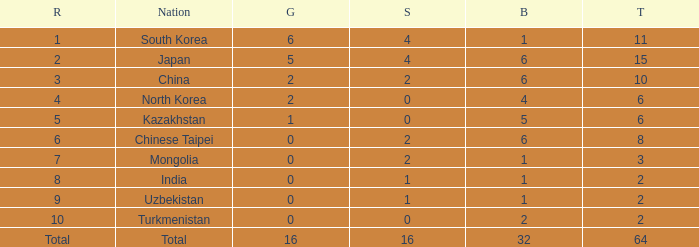What is the total Gold's less than 0? 0.0. 